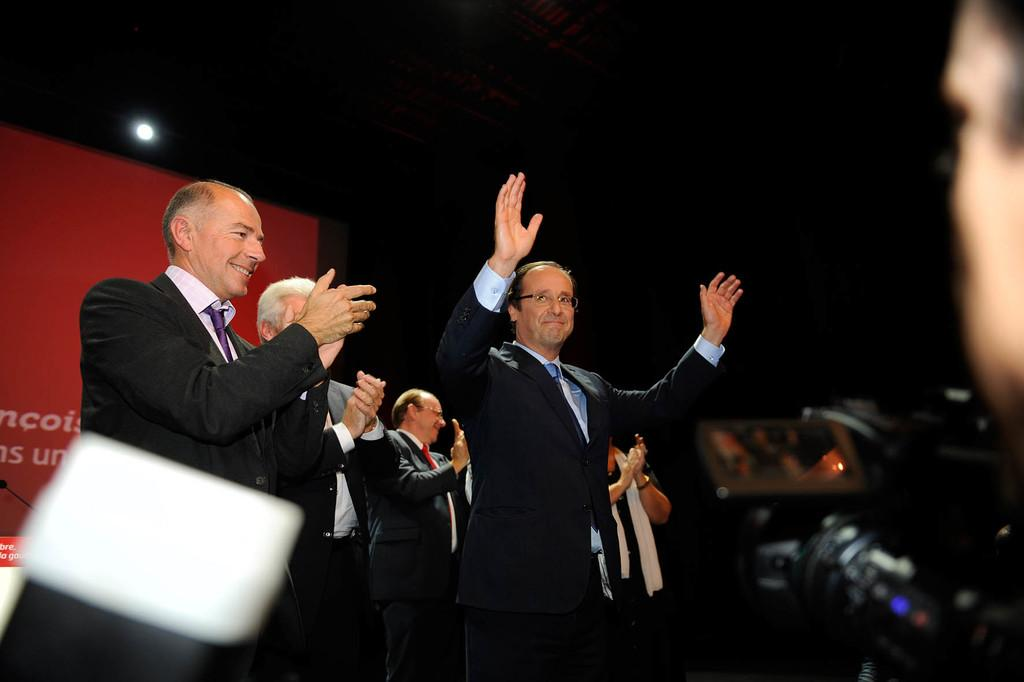What are the persons in the image wearing? The persons in the image are wearing suits and ties. What are the persons in the image doing? The persons are standing. What can be seen in the background of the image? There is a banner in the background of the image. What is located on the right side of the image? There is a camera on the right side of the image. Who is beside the camera? There is a person beside the camera. What type of plastic pail is being used by the person in the image? There is no plastic pail present in the image. What school event is taking place in the image? There is no indication of a school event in the image. 